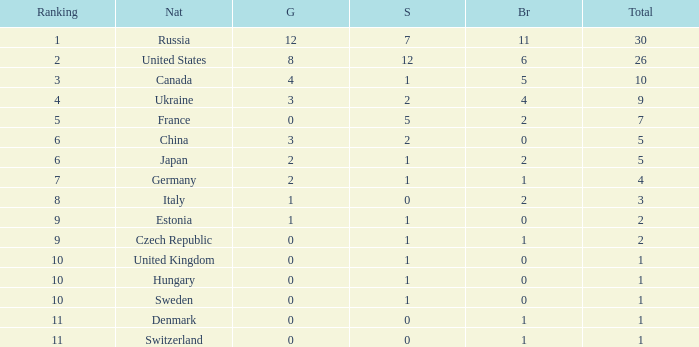What is the largest silver with Gold larger than 4, a Nation of united states, and a Total larger than 26? None. 